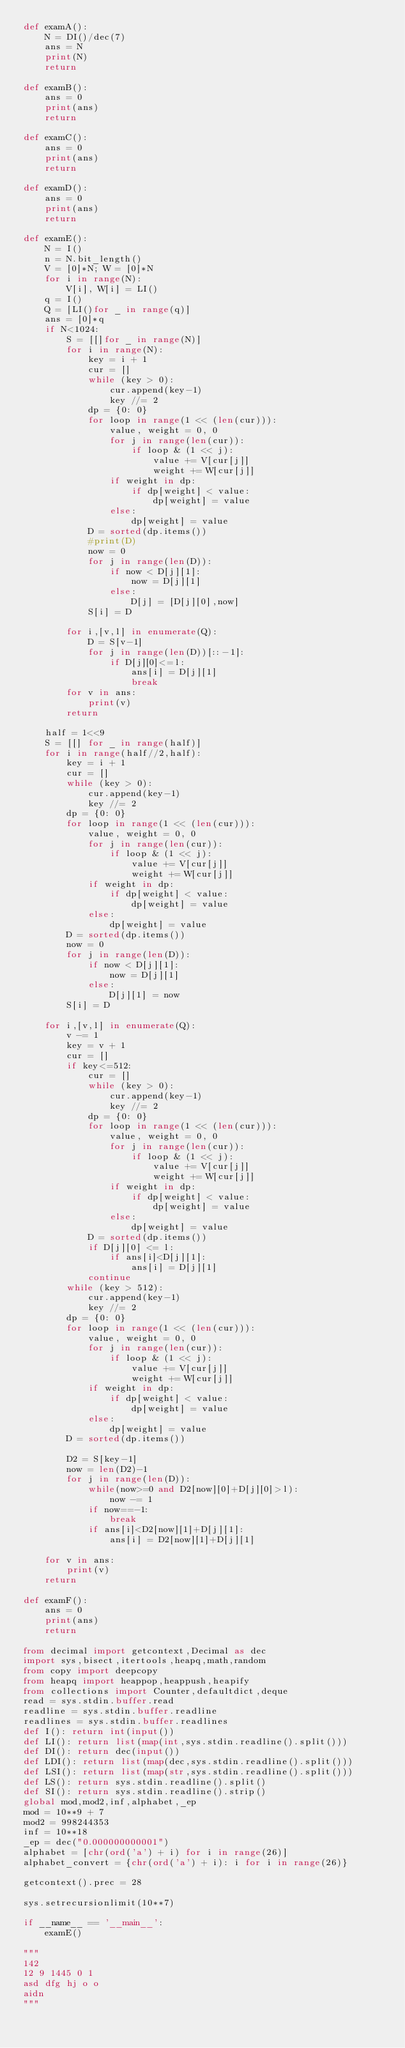<code> <loc_0><loc_0><loc_500><loc_500><_Python_>def examA():
    N = DI()/dec(7)
    ans = N
    print(N)
    return

def examB():
    ans = 0
    print(ans)
    return

def examC():
    ans = 0
    print(ans)
    return

def examD():
    ans = 0
    print(ans)
    return

def examE():
    N = I()
    n = N.bit_length()
    V = [0]*N; W = [0]*N
    for i in range(N):
        V[i], W[i] = LI()
    q = I()
    Q = [LI()for _ in range(q)]
    ans = [0]*q
    if N<1024:
        S = [[]for _ in range(N)]
        for i in range(N):
            key = i + 1
            cur = []
            while (key > 0):
                cur.append(key-1)
                key //= 2
            dp = {0: 0}
            for loop in range(1 << (len(cur))):
                value, weight = 0, 0
                for j in range(len(cur)):
                    if loop & (1 << j):
                        value += V[cur[j]]
                        weight += W[cur[j]]
                if weight in dp:
                    if dp[weight] < value:
                        dp[weight] = value
                else:
                    dp[weight] = value
            D = sorted(dp.items())
            #print(D)
            now = 0
            for j in range(len(D)):
                if now < D[j][1]:
                    now = D[j][1]
                else:
                    D[j] = [D[j][0],now]
            S[i] = D

        for i,[v,l] in enumerate(Q):
            D = S[v-1]
            for j in range(len(D))[::-1]:
                if D[j][0]<=l:
                    ans[i] = D[j][1]
                    break
        for v in ans:
            print(v)
        return

    half = 1<<9
    S = [[] for _ in range(half)]
    for i in range(half//2,half):
        key = i + 1
        cur = []
        while (key > 0):
            cur.append(key-1)
            key //= 2
        dp = {0: 0}
        for loop in range(1 << (len(cur))):
            value, weight = 0, 0
            for j in range(len(cur)):
                if loop & (1 << j):
                    value += V[cur[j]]
                    weight += W[cur[j]]
            if weight in dp:
                if dp[weight] < value:
                    dp[weight] = value
            else:
                dp[weight] = value
        D = sorted(dp.items())
        now = 0
        for j in range(len(D)):
            if now < D[j][1]:
                now = D[j][1]
            else:
                D[j][1] = now
        S[i] = D

    for i,[v,l] in enumerate(Q):
        v -= 1
        key = v + 1
        cur = []
        if key<=512:
            cur = []
            while (key > 0):
                cur.append(key-1)
                key //= 2
            dp = {0: 0}
            for loop in range(1 << (len(cur))):
                value, weight = 0, 0
                for j in range(len(cur)):
                    if loop & (1 << j):
                        value += V[cur[j]]
                        weight += W[cur[j]]
                if weight in dp:
                    if dp[weight] < value:
                        dp[weight] = value
                else:
                    dp[weight] = value
            D = sorted(dp.items())
            if D[j][0] <= l:
                if ans[i]<D[j][1]:
                    ans[i] = D[j][1]
            continue
        while (key > 512):
            cur.append(key-1)
            key //= 2
        dp = {0: 0}
        for loop in range(1 << (len(cur))):
            value, weight = 0, 0
            for j in range(len(cur)):
                if loop & (1 << j):
                    value += V[cur[j]]
                    weight += W[cur[j]]
            if weight in dp:
                if dp[weight] < value:
                    dp[weight] = value
            else:
                dp[weight] = value
        D = sorted(dp.items())

        D2 = S[key-1]
        now = len(D2)-1
        for j in range(len(D)):
            while(now>=0 and D2[now][0]+D[j][0]>l):
                now -= 1
            if now==-1:
                break
            if ans[i]<D2[now][1]+D[j][1]:
                ans[i] = D2[now][1]+D[j][1]

    for v in ans:
        print(v)
    return

def examF():
    ans = 0
    print(ans)
    return

from decimal import getcontext,Decimal as dec
import sys,bisect,itertools,heapq,math,random
from copy import deepcopy
from heapq import heappop,heappush,heapify
from collections import Counter,defaultdict,deque
read = sys.stdin.buffer.read
readline = sys.stdin.buffer.readline
readlines = sys.stdin.buffer.readlines
def I(): return int(input())
def LI(): return list(map(int,sys.stdin.readline().split()))
def DI(): return dec(input())
def LDI(): return list(map(dec,sys.stdin.readline().split()))
def LSI(): return list(map(str,sys.stdin.readline().split()))
def LS(): return sys.stdin.readline().split()
def SI(): return sys.stdin.readline().strip()
global mod,mod2,inf,alphabet,_ep
mod = 10**9 + 7
mod2 = 998244353
inf = 10**18
_ep = dec("0.000000000001")
alphabet = [chr(ord('a') + i) for i in range(26)]
alphabet_convert = {chr(ord('a') + i): i for i in range(26)}

getcontext().prec = 28

sys.setrecursionlimit(10**7)

if __name__ == '__main__':
    examE()

"""
142
12 9 1445 0 1
asd dfg hj o o
aidn
"""</code> 